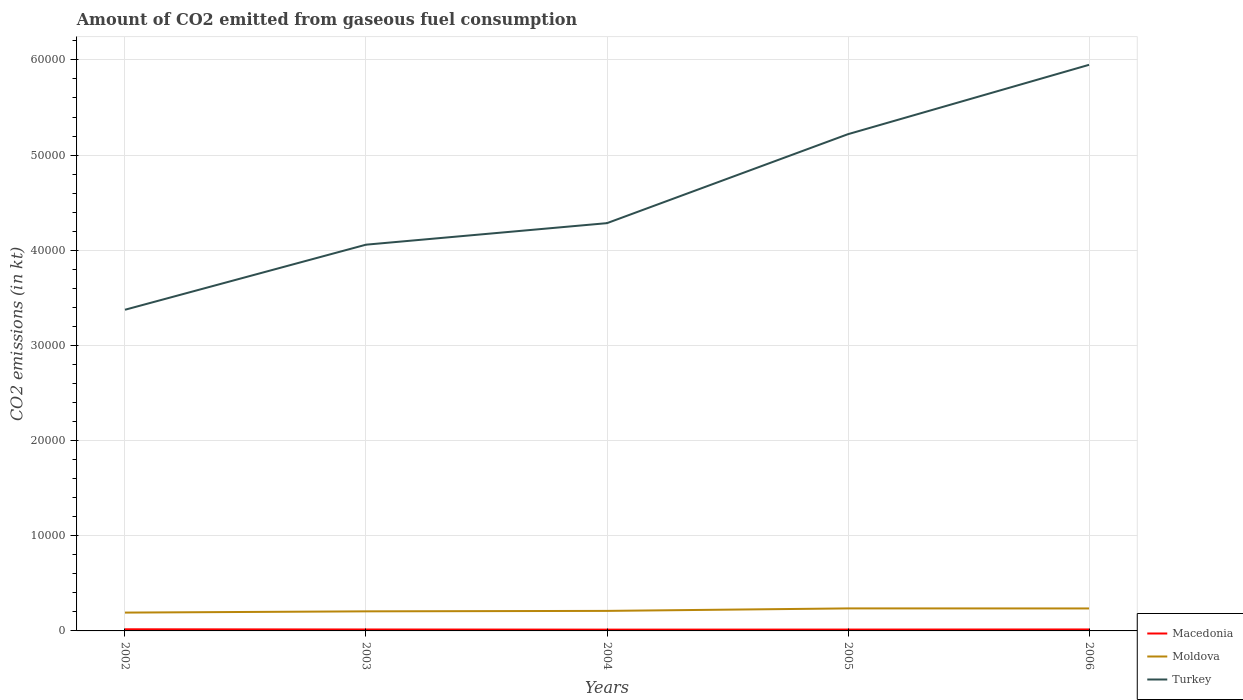Does the line corresponding to Moldova intersect with the line corresponding to Macedonia?
Make the answer very short. No. Is the number of lines equal to the number of legend labels?
Ensure brevity in your answer.  Yes. Across all years, what is the maximum amount of CO2 emitted in Turkey?
Keep it short and to the point. 3.37e+04. What is the total amount of CO2 emitted in Macedonia in the graph?
Your response must be concise. 7.33. What is the difference between the highest and the second highest amount of CO2 emitted in Moldova?
Offer a terse response. 440.04. What is the difference between the highest and the lowest amount of CO2 emitted in Turkey?
Keep it short and to the point. 2. How many years are there in the graph?
Provide a succinct answer. 5. What is the difference between two consecutive major ticks on the Y-axis?
Your answer should be very brief. 10000. Are the values on the major ticks of Y-axis written in scientific E-notation?
Provide a short and direct response. No. Does the graph contain any zero values?
Your response must be concise. No. Does the graph contain grids?
Provide a succinct answer. Yes. Where does the legend appear in the graph?
Give a very brief answer. Bottom right. How are the legend labels stacked?
Your answer should be compact. Vertical. What is the title of the graph?
Offer a terse response. Amount of CO2 emitted from gaseous fuel consumption. Does "High income: OECD" appear as one of the legend labels in the graph?
Provide a short and direct response. No. What is the label or title of the X-axis?
Your response must be concise. Years. What is the label or title of the Y-axis?
Ensure brevity in your answer.  CO2 emissions (in kt). What is the CO2 emissions (in kt) of Macedonia in 2002?
Make the answer very short. 172.35. What is the CO2 emissions (in kt) in Moldova in 2002?
Provide a succinct answer. 1925.17. What is the CO2 emissions (in kt) of Turkey in 2002?
Ensure brevity in your answer.  3.37e+04. What is the CO2 emissions (in kt) in Macedonia in 2003?
Your answer should be compact. 150.35. What is the CO2 emissions (in kt) of Moldova in 2003?
Offer a terse response. 2057.19. What is the CO2 emissions (in kt) in Turkey in 2003?
Offer a very short reply. 4.06e+04. What is the CO2 emissions (in kt) of Macedonia in 2004?
Give a very brief answer. 135.68. What is the CO2 emissions (in kt) of Moldova in 2004?
Your response must be concise. 2104.86. What is the CO2 emissions (in kt) of Turkey in 2004?
Provide a short and direct response. 4.28e+04. What is the CO2 emissions (in kt) of Macedonia in 2005?
Your answer should be very brief. 143.01. What is the CO2 emissions (in kt) in Moldova in 2005?
Make the answer very short. 2365.22. What is the CO2 emissions (in kt) in Turkey in 2005?
Keep it short and to the point. 5.22e+04. What is the CO2 emissions (in kt) of Macedonia in 2006?
Make the answer very short. 154.01. What is the CO2 emissions (in kt) of Moldova in 2006?
Give a very brief answer. 2361.55. What is the CO2 emissions (in kt) in Turkey in 2006?
Ensure brevity in your answer.  5.95e+04. Across all years, what is the maximum CO2 emissions (in kt) of Macedonia?
Provide a short and direct response. 172.35. Across all years, what is the maximum CO2 emissions (in kt) of Moldova?
Provide a short and direct response. 2365.22. Across all years, what is the maximum CO2 emissions (in kt) in Turkey?
Your answer should be compact. 5.95e+04. Across all years, what is the minimum CO2 emissions (in kt) in Macedonia?
Your answer should be compact. 135.68. Across all years, what is the minimum CO2 emissions (in kt) of Moldova?
Give a very brief answer. 1925.17. Across all years, what is the minimum CO2 emissions (in kt) of Turkey?
Provide a short and direct response. 3.37e+04. What is the total CO2 emissions (in kt) in Macedonia in the graph?
Your response must be concise. 755.4. What is the total CO2 emissions (in kt) in Moldova in the graph?
Provide a succinct answer. 1.08e+04. What is the total CO2 emissions (in kt) in Turkey in the graph?
Provide a succinct answer. 2.29e+05. What is the difference between the CO2 emissions (in kt) in Macedonia in 2002 and that in 2003?
Your answer should be compact. 22. What is the difference between the CO2 emissions (in kt) of Moldova in 2002 and that in 2003?
Offer a very short reply. -132.01. What is the difference between the CO2 emissions (in kt) in Turkey in 2002 and that in 2003?
Make the answer very short. -6838.95. What is the difference between the CO2 emissions (in kt) in Macedonia in 2002 and that in 2004?
Give a very brief answer. 36.67. What is the difference between the CO2 emissions (in kt) in Moldova in 2002 and that in 2004?
Ensure brevity in your answer.  -179.68. What is the difference between the CO2 emissions (in kt) of Turkey in 2002 and that in 2004?
Offer a very short reply. -9101.49. What is the difference between the CO2 emissions (in kt) in Macedonia in 2002 and that in 2005?
Your answer should be compact. 29.34. What is the difference between the CO2 emissions (in kt) in Moldova in 2002 and that in 2005?
Your answer should be very brief. -440.04. What is the difference between the CO2 emissions (in kt) of Turkey in 2002 and that in 2005?
Make the answer very short. -1.85e+04. What is the difference between the CO2 emissions (in kt) of Macedonia in 2002 and that in 2006?
Ensure brevity in your answer.  18.34. What is the difference between the CO2 emissions (in kt) in Moldova in 2002 and that in 2006?
Provide a short and direct response. -436.37. What is the difference between the CO2 emissions (in kt) in Turkey in 2002 and that in 2006?
Provide a short and direct response. -2.57e+04. What is the difference between the CO2 emissions (in kt) of Macedonia in 2003 and that in 2004?
Your answer should be very brief. 14.67. What is the difference between the CO2 emissions (in kt) of Moldova in 2003 and that in 2004?
Provide a succinct answer. -47.67. What is the difference between the CO2 emissions (in kt) in Turkey in 2003 and that in 2004?
Make the answer very short. -2262.54. What is the difference between the CO2 emissions (in kt) of Macedonia in 2003 and that in 2005?
Provide a succinct answer. 7.33. What is the difference between the CO2 emissions (in kt) in Moldova in 2003 and that in 2005?
Keep it short and to the point. -308.03. What is the difference between the CO2 emissions (in kt) of Turkey in 2003 and that in 2005?
Your answer should be compact. -1.16e+04. What is the difference between the CO2 emissions (in kt) of Macedonia in 2003 and that in 2006?
Make the answer very short. -3.67. What is the difference between the CO2 emissions (in kt) of Moldova in 2003 and that in 2006?
Your answer should be very brief. -304.36. What is the difference between the CO2 emissions (in kt) of Turkey in 2003 and that in 2006?
Keep it short and to the point. -1.89e+04. What is the difference between the CO2 emissions (in kt) in Macedonia in 2004 and that in 2005?
Offer a very short reply. -7.33. What is the difference between the CO2 emissions (in kt) of Moldova in 2004 and that in 2005?
Give a very brief answer. -260.36. What is the difference between the CO2 emissions (in kt) in Turkey in 2004 and that in 2005?
Your answer should be compact. -9350.85. What is the difference between the CO2 emissions (in kt) in Macedonia in 2004 and that in 2006?
Make the answer very short. -18.34. What is the difference between the CO2 emissions (in kt) in Moldova in 2004 and that in 2006?
Your answer should be very brief. -256.69. What is the difference between the CO2 emissions (in kt) of Turkey in 2004 and that in 2006?
Give a very brief answer. -1.66e+04. What is the difference between the CO2 emissions (in kt) in Macedonia in 2005 and that in 2006?
Make the answer very short. -11. What is the difference between the CO2 emissions (in kt) of Moldova in 2005 and that in 2006?
Ensure brevity in your answer.  3.67. What is the difference between the CO2 emissions (in kt) in Turkey in 2005 and that in 2006?
Provide a short and direct response. -7286.33. What is the difference between the CO2 emissions (in kt) of Macedonia in 2002 and the CO2 emissions (in kt) of Moldova in 2003?
Provide a short and direct response. -1884.84. What is the difference between the CO2 emissions (in kt) of Macedonia in 2002 and the CO2 emissions (in kt) of Turkey in 2003?
Your response must be concise. -4.04e+04. What is the difference between the CO2 emissions (in kt) in Moldova in 2002 and the CO2 emissions (in kt) in Turkey in 2003?
Your answer should be very brief. -3.87e+04. What is the difference between the CO2 emissions (in kt) of Macedonia in 2002 and the CO2 emissions (in kt) of Moldova in 2004?
Make the answer very short. -1932.51. What is the difference between the CO2 emissions (in kt) in Macedonia in 2002 and the CO2 emissions (in kt) in Turkey in 2004?
Provide a short and direct response. -4.27e+04. What is the difference between the CO2 emissions (in kt) in Moldova in 2002 and the CO2 emissions (in kt) in Turkey in 2004?
Your response must be concise. -4.09e+04. What is the difference between the CO2 emissions (in kt) of Macedonia in 2002 and the CO2 emissions (in kt) of Moldova in 2005?
Offer a very short reply. -2192.87. What is the difference between the CO2 emissions (in kt) of Macedonia in 2002 and the CO2 emissions (in kt) of Turkey in 2005?
Your answer should be compact. -5.20e+04. What is the difference between the CO2 emissions (in kt) in Moldova in 2002 and the CO2 emissions (in kt) in Turkey in 2005?
Your answer should be compact. -5.03e+04. What is the difference between the CO2 emissions (in kt) of Macedonia in 2002 and the CO2 emissions (in kt) of Moldova in 2006?
Provide a succinct answer. -2189.2. What is the difference between the CO2 emissions (in kt) in Macedonia in 2002 and the CO2 emissions (in kt) in Turkey in 2006?
Your answer should be compact. -5.93e+04. What is the difference between the CO2 emissions (in kt) in Moldova in 2002 and the CO2 emissions (in kt) in Turkey in 2006?
Provide a short and direct response. -5.76e+04. What is the difference between the CO2 emissions (in kt) of Macedonia in 2003 and the CO2 emissions (in kt) of Moldova in 2004?
Make the answer very short. -1954.51. What is the difference between the CO2 emissions (in kt) of Macedonia in 2003 and the CO2 emissions (in kt) of Turkey in 2004?
Your answer should be compact. -4.27e+04. What is the difference between the CO2 emissions (in kt) in Moldova in 2003 and the CO2 emissions (in kt) in Turkey in 2004?
Ensure brevity in your answer.  -4.08e+04. What is the difference between the CO2 emissions (in kt) of Macedonia in 2003 and the CO2 emissions (in kt) of Moldova in 2005?
Keep it short and to the point. -2214.87. What is the difference between the CO2 emissions (in kt) in Macedonia in 2003 and the CO2 emissions (in kt) in Turkey in 2005?
Keep it short and to the point. -5.20e+04. What is the difference between the CO2 emissions (in kt) in Moldova in 2003 and the CO2 emissions (in kt) in Turkey in 2005?
Your response must be concise. -5.01e+04. What is the difference between the CO2 emissions (in kt) of Macedonia in 2003 and the CO2 emissions (in kt) of Moldova in 2006?
Your response must be concise. -2211.2. What is the difference between the CO2 emissions (in kt) of Macedonia in 2003 and the CO2 emissions (in kt) of Turkey in 2006?
Keep it short and to the point. -5.93e+04. What is the difference between the CO2 emissions (in kt) of Moldova in 2003 and the CO2 emissions (in kt) of Turkey in 2006?
Offer a terse response. -5.74e+04. What is the difference between the CO2 emissions (in kt) in Macedonia in 2004 and the CO2 emissions (in kt) in Moldova in 2005?
Give a very brief answer. -2229.54. What is the difference between the CO2 emissions (in kt) of Macedonia in 2004 and the CO2 emissions (in kt) of Turkey in 2005?
Give a very brief answer. -5.21e+04. What is the difference between the CO2 emissions (in kt) of Moldova in 2004 and the CO2 emissions (in kt) of Turkey in 2005?
Make the answer very short. -5.01e+04. What is the difference between the CO2 emissions (in kt) of Macedonia in 2004 and the CO2 emissions (in kt) of Moldova in 2006?
Keep it short and to the point. -2225.87. What is the difference between the CO2 emissions (in kt) of Macedonia in 2004 and the CO2 emissions (in kt) of Turkey in 2006?
Offer a very short reply. -5.94e+04. What is the difference between the CO2 emissions (in kt) of Moldova in 2004 and the CO2 emissions (in kt) of Turkey in 2006?
Offer a terse response. -5.74e+04. What is the difference between the CO2 emissions (in kt) in Macedonia in 2005 and the CO2 emissions (in kt) in Moldova in 2006?
Your answer should be compact. -2218.53. What is the difference between the CO2 emissions (in kt) in Macedonia in 2005 and the CO2 emissions (in kt) in Turkey in 2006?
Provide a succinct answer. -5.93e+04. What is the difference between the CO2 emissions (in kt) in Moldova in 2005 and the CO2 emissions (in kt) in Turkey in 2006?
Ensure brevity in your answer.  -5.71e+04. What is the average CO2 emissions (in kt) in Macedonia per year?
Your answer should be compact. 151.08. What is the average CO2 emissions (in kt) in Moldova per year?
Give a very brief answer. 2162.8. What is the average CO2 emissions (in kt) in Turkey per year?
Give a very brief answer. 4.58e+04. In the year 2002, what is the difference between the CO2 emissions (in kt) of Macedonia and CO2 emissions (in kt) of Moldova?
Your response must be concise. -1752.83. In the year 2002, what is the difference between the CO2 emissions (in kt) of Macedonia and CO2 emissions (in kt) of Turkey?
Provide a short and direct response. -3.36e+04. In the year 2002, what is the difference between the CO2 emissions (in kt) of Moldova and CO2 emissions (in kt) of Turkey?
Ensure brevity in your answer.  -3.18e+04. In the year 2003, what is the difference between the CO2 emissions (in kt) of Macedonia and CO2 emissions (in kt) of Moldova?
Provide a short and direct response. -1906.84. In the year 2003, what is the difference between the CO2 emissions (in kt) in Macedonia and CO2 emissions (in kt) in Turkey?
Give a very brief answer. -4.04e+04. In the year 2003, what is the difference between the CO2 emissions (in kt) of Moldova and CO2 emissions (in kt) of Turkey?
Ensure brevity in your answer.  -3.85e+04. In the year 2004, what is the difference between the CO2 emissions (in kt) of Macedonia and CO2 emissions (in kt) of Moldova?
Offer a terse response. -1969.18. In the year 2004, what is the difference between the CO2 emissions (in kt) of Macedonia and CO2 emissions (in kt) of Turkey?
Make the answer very short. -4.27e+04. In the year 2004, what is the difference between the CO2 emissions (in kt) of Moldova and CO2 emissions (in kt) of Turkey?
Your answer should be compact. -4.07e+04. In the year 2005, what is the difference between the CO2 emissions (in kt) in Macedonia and CO2 emissions (in kt) in Moldova?
Keep it short and to the point. -2222.2. In the year 2005, what is the difference between the CO2 emissions (in kt) in Macedonia and CO2 emissions (in kt) in Turkey?
Offer a very short reply. -5.21e+04. In the year 2005, what is the difference between the CO2 emissions (in kt) of Moldova and CO2 emissions (in kt) of Turkey?
Give a very brief answer. -4.98e+04. In the year 2006, what is the difference between the CO2 emissions (in kt) in Macedonia and CO2 emissions (in kt) in Moldova?
Your answer should be compact. -2207.53. In the year 2006, what is the difference between the CO2 emissions (in kt) of Macedonia and CO2 emissions (in kt) of Turkey?
Provide a short and direct response. -5.93e+04. In the year 2006, what is the difference between the CO2 emissions (in kt) of Moldova and CO2 emissions (in kt) of Turkey?
Your answer should be compact. -5.71e+04. What is the ratio of the CO2 emissions (in kt) in Macedonia in 2002 to that in 2003?
Provide a short and direct response. 1.15. What is the ratio of the CO2 emissions (in kt) of Moldova in 2002 to that in 2003?
Your answer should be very brief. 0.94. What is the ratio of the CO2 emissions (in kt) of Turkey in 2002 to that in 2003?
Ensure brevity in your answer.  0.83. What is the ratio of the CO2 emissions (in kt) of Macedonia in 2002 to that in 2004?
Your answer should be compact. 1.27. What is the ratio of the CO2 emissions (in kt) of Moldova in 2002 to that in 2004?
Provide a succinct answer. 0.91. What is the ratio of the CO2 emissions (in kt) of Turkey in 2002 to that in 2004?
Keep it short and to the point. 0.79. What is the ratio of the CO2 emissions (in kt) of Macedonia in 2002 to that in 2005?
Make the answer very short. 1.21. What is the ratio of the CO2 emissions (in kt) of Moldova in 2002 to that in 2005?
Offer a very short reply. 0.81. What is the ratio of the CO2 emissions (in kt) of Turkey in 2002 to that in 2005?
Provide a short and direct response. 0.65. What is the ratio of the CO2 emissions (in kt) in Macedonia in 2002 to that in 2006?
Keep it short and to the point. 1.12. What is the ratio of the CO2 emissions (in kt) in Moldova in 2002 to that in 2006?
Provide a succinct answer. 0.82. What is the ratio of the CO2 emissions (in kt) in Turkey in 2002 to that in 2006?
Your answer should be very brief. 0.57. What is the ratio of the CO2 emissions (in kt) of Macedonia in 2003 to that in 2004?
Keep it short and to the point. 1.11. What is the ratio of the CO2 emissions (in kt) of Moldova in 2003 to that in 2004?
Ensure brevity in your answer.  0.98. What is the ratio of the CO2 emissions (in kt) of Turkey in 2003 to that in 2004?
Your response must be concise. 0.95. What is the ratio of the CO2 emissions (in kt) in Macedonia in 2003 to that in 2005?
Your answer should be compact. 1.05. What is the ratio of the CO2 emissions (in kt) in Moldova in 2003 to that in 2005?
Offer a very short reply. 0.87. What is the ratio of the CO2 emissions (in kt) in Turkey in 2003 to that in 2005?
Offer a very short reply. 0.78. What is the ratio of the CO2 emissions (in kt) in Macedonia in 2003 to that in 2006?
Ensure brevity in your answer.  0.98. What is the ratio of the CO2 emissions (in kt) in Moldova in 2003 to that in 2006?
Offer a terse response. 0.87. What is the ratio of the CO2 emissions (in kt) in Turkey in 2003 to that in 2006?
Provide a succinct answer. 0.68. What is the ratio of the CO2 emissions (in kt) in Macedonia in 2004 to that in 2005?
Ensure brevity in your answer.  0.95. What is the ratio of the CO2 emissions (in kt) in Moldova in 2004 to that in 2005?
Offer a terse response. 0.89. What is the ratio of the CO2 emissions (in kt) of Turkey in 2004 to that in 2005?
Keep it short and to the point. 0.82. What is the ratio of the CO2 emissions (in kt) of Macedonia in 2004 to that in 2006?
Your response must be concise. 0.88. What is the ratio of the CO2 emissions (in kt) in Moldova in 2004 to that in 2006?
Make the answer very short. 0.89. What is the ratio of the CO2 emissions (in kt) of Turkey in 2004 to that in 2006?
Your response must be concise. 0.72. What is the ratio of the CO2 emissions (in kt) in Macedonia in 2005 to that in 2006?
Give a very brief answer. 0.93. What is the ratio of the CO2 emissions (in kt) of Moldova in 2005 to that in 2006?
Provide a succinct answer. 1. What is the ratio of the CO2 emissions (in kt) of Turkey in 2005 to that in 2006?
Give a very brief answer. 0.88. What is the difference between the highest and the second highest CO2 emissions (in kt) in Macedonia?
Give a very brief answer. 18.34. What is the difference between the highest and the second highest CO2 emissions (in kt) of Moldova?
Keep it short and to the point. 3.67. What is the difference between the highest and the second highest CO2 emissions (in kt) in Turkey?
Your response must be concise. 7286.33. What is the difference between the highest and the lowest CO2 emissions (in kt) in Macedonia?
Keep it short and to the point. 36.67. What is the difference between the highest and the lowest CO2 emissions (in kt) in Moldova?
Provide a short and direct response. 440.04. What is the difference between the highest and the lowest CO2 emissions (in kt) of Turkey?
Your answer should be very brief. 2.57e+04. 